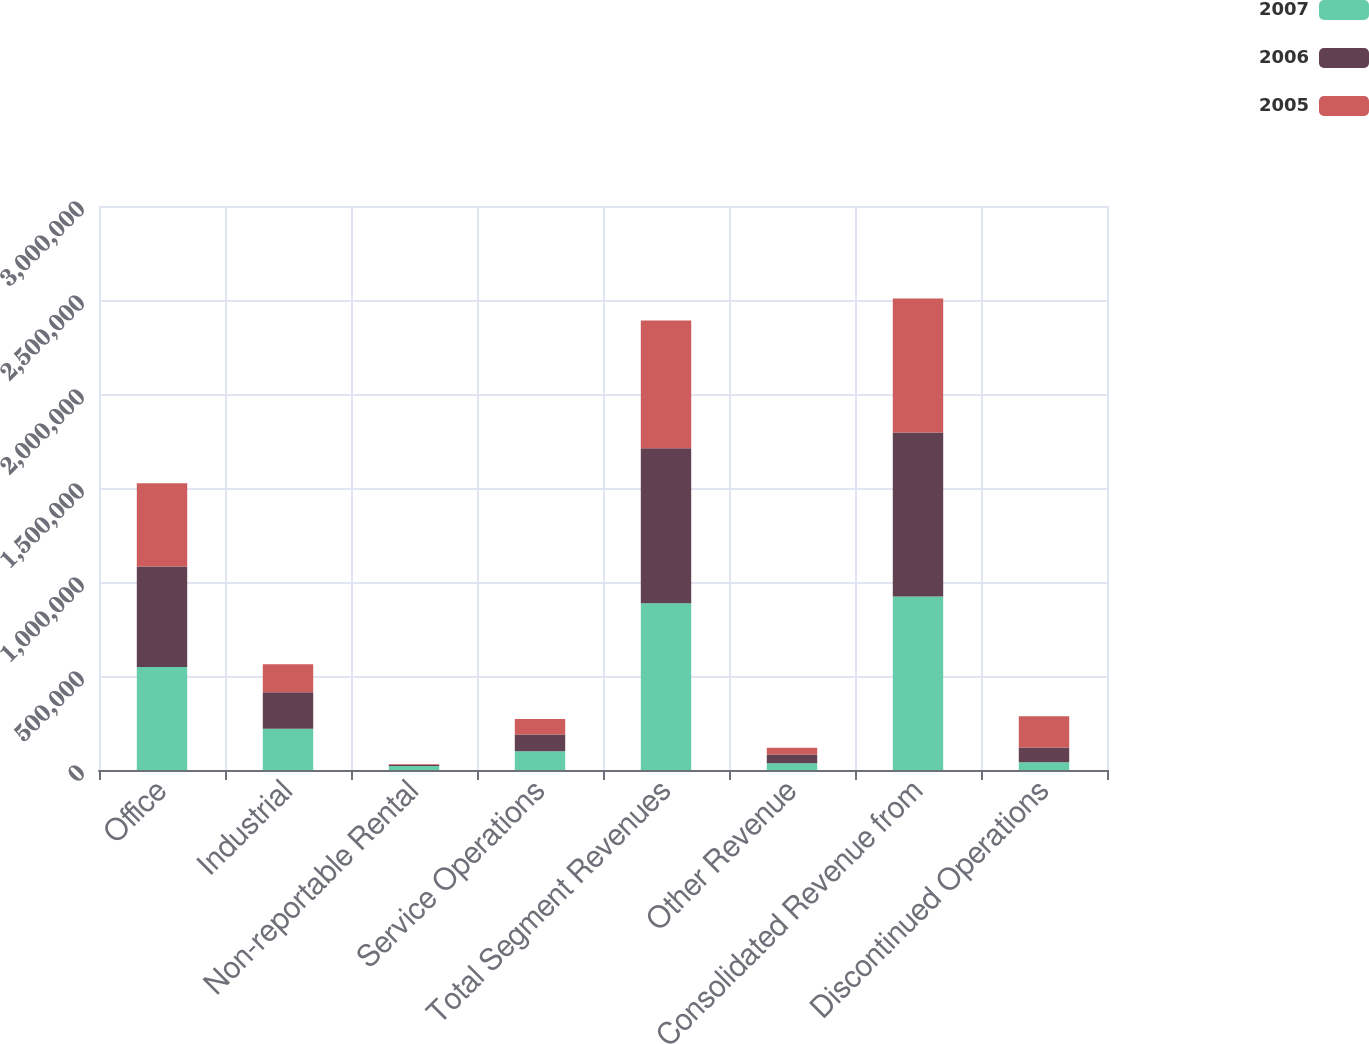<chart> <loc_0><loc_0><loc_500><loc_500><stacked_bar_chart><ecel><fcel>Office<fcel>Industrial<fcel>Non-reportable Rental<fcel>Service Operations<fcel>Total Segment Revenues<fcel>Other Revenue<fcel>Consolidated Revenue from<fcel>Discontinued Operations<nl><fcel>2007<fcel>547478<fcel>219080<fcel>20952<fcel>99358<fcel>886868<fcel>36359<fcel>923227<fcel>41117<nl><fcel>2006<fcel>534369<fcel>194670<fcel>5775<fcel>90125<fcel>824939<fcel>46738<fcel>871677<fcel>77975<nl><fcel>2005<fcel>443927<fcel>148359<fcel>4449<fcel>81941<fcel>678676<fcel>34876<fcel>713552<fcel>166235<nl></chart> 